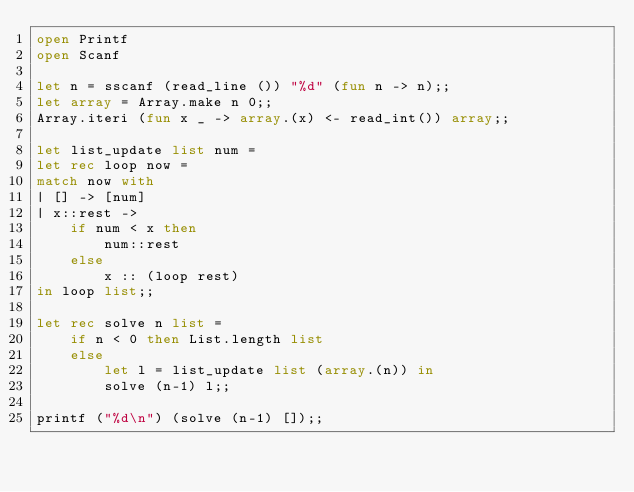Convert code to text. <code><loc_0><loc_0><loc_500><loc_500><_OCaml_>open Printf
open Scanf

let n = sscanf (read_line ()) "%d" (fun n -> n);;
let array = Array.make n 0;;
Array.iteri (fun x _ -> array.(x) <- read_int()) array;;

let list_update list num =
let rec loop now =
match now with
| [] -> [num]
| x::rest ->
    if num < x then
        num::rest
    else
        x :: (loop rest)
in loop list;;

let rec solve n list =
    if n < 0 then List.length list
    else 
        let l = list_update list (array.(n)) in
        solve (n-1) l;;

printf ("%d\n") (solve (n-1) []);;</code> 